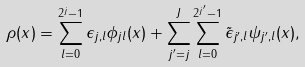Convert formula to latex. <formula><loc_0><loc_0><loc_500><loc_500>\rho ( x ) = \sum _ { l = 0 } ^ { 2 ^ { j } - 1 } \epsilon _ { j , l } \phi _ { j l } ( x ) + \sum _ { j ^ { \prime } = j } ^ { J } \sum _ { l = 0 } ^ { 2 ^ { j ^ { \prime } } - 1 } \tilde { \epsilon } _ { j ^ { \prime } , l } \psi _ { j ^ { \prime } , l } ( x ) ,</formula> 